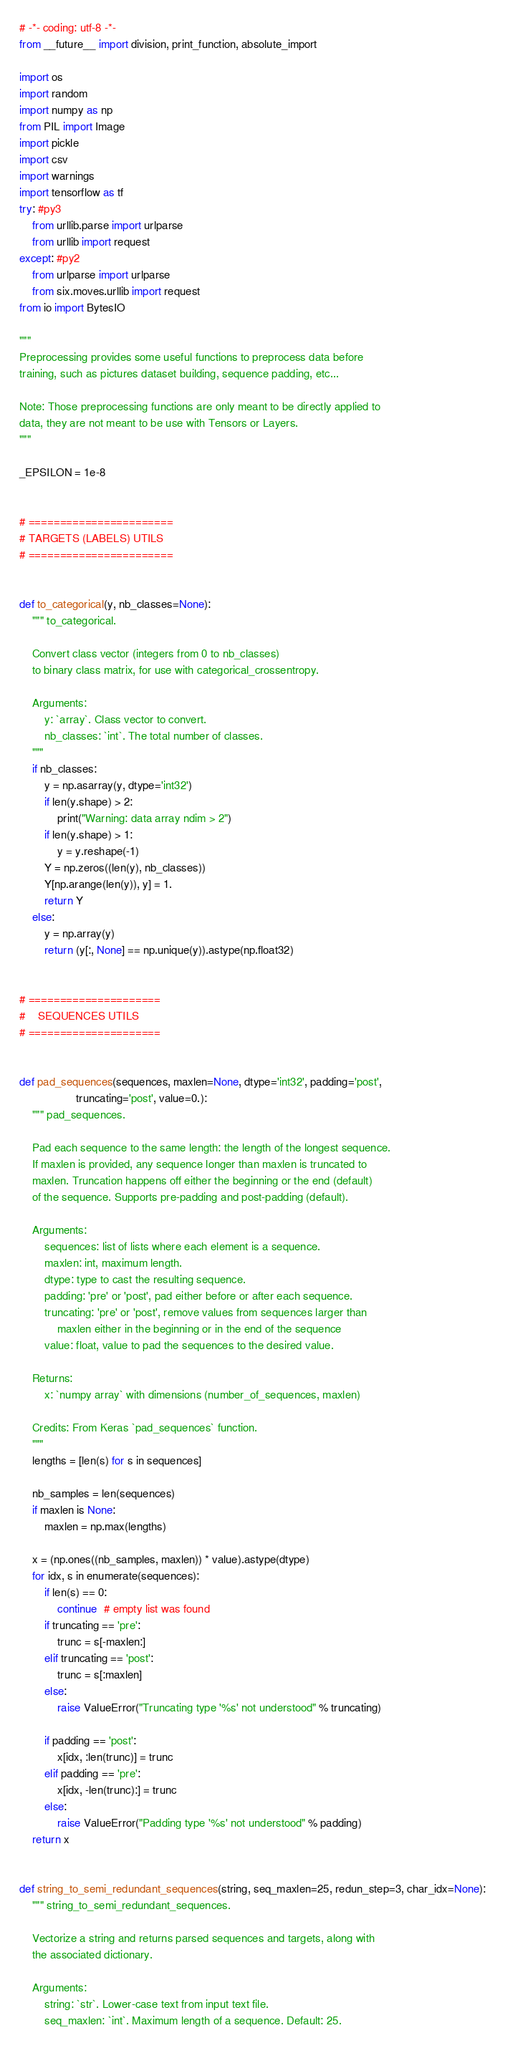Convert code to text. <code><loc_0><loc_0><loc_500><loc_500><_Python_># -*- coding: utf-8 -*-
from __future__ import division, print_function, absolute_import

import os
import random
import numpy as np
from PIL import Image
import pickle
import csv
import warnings
import tensorflow as tf
try: #py3
    from urllib.parse import urlparse
    from urllib import request
except: #py2
    from urlparse import urlparse
    from six.moves.urllib import request
from io import BytesIO

"""
Preprocessing provides some useful functions to preprocess data before
training, such as pictures dataset building, sequence padding, etc...

Note: Those preprocessing functions are only meant to be directly applied to
data, they are not meant to be use with Tensors or Layers.
"""

_EPSILON = 1e-8


# =======================
# TARGETS (LABELS) UTILS
# =======================


def to_categorical(y, nb_classes=None):
    """ to_categorical.

    Convert class vector (integers from 0 to nb_classes)
    to binary class matrix, for use with categorical_crossentropy.

    Arguments:
        y: `array`. Class vector to convert.
        nb_classes: `int`. The total number of classes.
    """
    if nb_classes:
        y = np.asarray(y, dtype='int32')
        if len(y.shape) > 2:
            print("Warning: data array ndim > 2")
        if len(y.shape) > 1:
            y = y.reshape(-1)
        Y = np.zeros((len(y), nb_classes))
        Y[np.arange(len(y)), y] = 1.
        return Y
    else:
        y = np.array(y)
        return (y[:, None] == np.unique(y)).astype(np.float32)


# =====================
#    SEQUENCES UTILS
# =====================


def pad_sequences(sequences, maxlen=None, dtype='int32', padding='post',
                  truncating='post', value=0.):
    """ pad_sequences.

    Pad each sequence to the same length: the length of the longest sequence.
    If maxlen is provided, any sequence longer than maxlen is truncated to
    maxlen. Truncation happens off either the beginning or the end (default)
    of the sequence. Supports pre-padding and post-padding (default).

    Arguments:
        sequences: list of lists where each element is a sequence.
        maxlen: int, maximum length.
        dtype: type to cast the resulting sequence.
        padding: 'pre' or 'post', pad either before or after each sequence.
        truncating: 'pre' or 'post', remove values from sequences larger than
            maxlen either in the beginning or in the end of the sequence
        value: float, value to pad the sequences to the desired value.

    Returns:
        x: `numpy array` with dimensions (number_of_sequences, maxlen)

    Credits: From Keras `pad_sequences` function.
    """
    lengths = [len(s) for s in sequences]

    nb_samples = len(sequences)
    if maxlen is None:
        maxlen = np.max(lengths)

    x = (np.ones((nb_samples, maxlen)) * value).astype(dtype)
    for idx, s in enumerate(sequences):
        if len(s) == 0:
            continue  # empty list was found
        if truncating == 'pre':
            trunc = s[-maxlen:]
        elif truncating == 'post':
            trunc = s[:maxlen]
        else:
            raise ValueError("Truncating type '%s' not understood" % truncating)

        if padding == 'post':
            x[idx, :len(trunc)] = trunc
        elif padding == 'pre':
            x[idx, -len(trunc):] = trunc
        else:
            raise ValueError("Padding type '%s' not understood" % padding)
    return x


def string_to_semi_redundant_sequences(string, seq_maxlen=25, redun_step=3, char_idx=None):
    """ string_to_semi_redundant_sequences.

    Vectorize a string and returns parsed sequences and targets, along with
    the associated dictionary.

    Arguments:
        string: `str`. Lower-case text from input text file.
        seq_maxlen: `int`. Maximum length of a sequence. Default: 25.</code> 